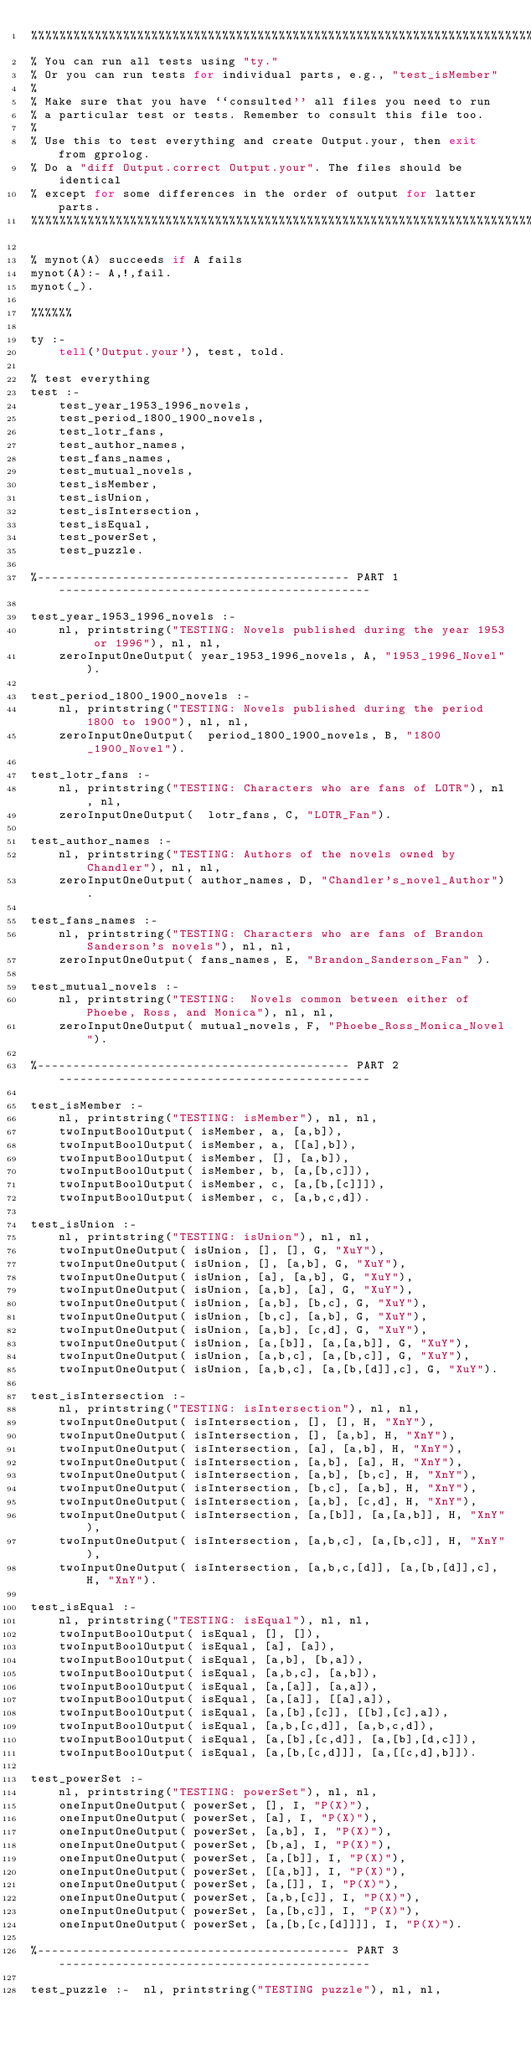<code> <loc_0><loc_0><loc_500><loc_500><_Perl_>%%%%%%%%%%%%%%%%%%%%%%%%%%%%%%%%%%%%%%%%%%%%%%%%%%%%%%%%%%%%%%%%%%%%%%%%%%%
% You can run all tests using "ty." 
% Or you can run tests for individual parts, e.g., "test_isMember"
%
% Make sure that you have ``consulted'' all files you need to run 
% a particular test or tests. Remember to consult this file too.
%
% Use this to test everything and create Output.your, then exit from gprolog.
% Do a "diff Output.correct Output.your". The files should be identical
% except for some differences in the order of output for latter parts.
%%%%%%%%%%%%%%%%%%%%%%%%%%%%%%%%%%%%%%%%%%%%%%%%%%%%%%%%%%%%%%%%%%%%%%%%%%%

% mynot(A) succeeds if A fails
mynot(A):- A,!,fail.
mynot(_).

%%%%%%

ty :-
	tell('Output.your'), test, told.

% test everything
test :-
	test_year_1953_1996_novels,
	test_period_1800_1900_novels,
	test_lotr_fans,
	test_author_names,
	test_fans_names,
	test_mutual_novels,
	test_isMember,
	test_isUnion,
	test_isIntersection,
    test_isEqual,
    test_powerSet,
    test_puzzle.

%-------------------------------------------- PART 1 --------------------------------------------

test_year_1953_1996_novels :-
	nl, printstring("TESTING: Novels published during the year 1953 or 1996"), nl, nl,
	zeroInputOneOutput( year_1953_1996_novels, A, "1953_1996_Novel").

test_period_1800_1900_novels :-
	nl, printstring("TESTING: Novels published during the period 1800 to 1900"), nl, nl,
	zeroInputOneOutput(  period_1800_1900_novels, B, "1800_1900_Novel").

test_lotr_fans :-
	nl, printstring("TESTING: Characters who are fans of LOTR"), nl, nl,
	zeroInputOneOutput(  lotr_fans, C, "LOTR_Fan").

test_author_names :-
	nl, printstring("TESTING: Authors of the novels owned by Chandler"), nl, nl,
	zeroInputOneOutput( author_names, D, "Chandler's_novel_Author").

test_fans_names :-
	nl, printstring("TESTING: Characters who are fans of Brandon Sanderson's novels"), nl, nl,
	zeroInputOneOutput( fans_names, E, "Brandon_Sanderson_Fan" ).

test_mutual_novels :-
	nl, printstring("TESTING:  Novels common between either of Phoebe, Ross, and Monica"), nl, nl,
	zeroInputOneOutput( mutual_novels, F, "Phoebe_Ross_Monica_Novel").

%-------------------------------------------- PART 2 --------------------------------------------

test_isMember :-
	nl, printstring("TESTING: isMember"), nl, nl,
	twoInputBoolOutput( isMember, a, [a,b]),
	twoInputBoolOutput( isMember, a, [[a],b]),
	twoInputBoolOutput( isMember, [], [a,b]),
	twoInputBoolOutput( isMember, b, [a,[b,c]]),
	twoInputBoolOutput( isMember, c, [a,[b,[c]]]),
	twoInputBoolOutput( isMember, c, [a,b,c,d]).

test_isUnion :-
	nl, printstring("TESTING: isUnion"), nl, nl,
	twoInputOneOutput( isUnion, [], [], G, "XuY"),
	twoInputOneOutput( isUnion, [], [a,b], G, "XuY"),
	twoInputOneOutput( isUnion, [a], [a,b], G, "XuY"),
	twoInputOneOutput( isUnion, [a,b], [a], G, "XuY"),
	twoInputOneOutput( isUnion, [a,b], [b,c], G, "XuY"),
	twoInputOneOutput( isUnion, [b,c], [a,b], G, "XuY"),
	twoInputOneOutput( isUnion, [a,b], [c,d], G, "XuY"),
	twoInputOneOutput( isUnion, [a,[b]], [a,[a,b]], G, "XuY"),
	twoInputOneOutput( isUnion, [a,b,c], [a,[b,c]], G, "XuY"),
	twoInputOneOutput( isUnion, [a,b,c], [a,[b,[d]],c], G, "XuY").

test_isIntersection :-
	nl, printstring("TESTING: isIntersection"), nl, nl,
	twoInputOneOutput( isIntersection, [], [], H, "XnY"),
	twoInputOneOutput( isIntersection, [], [a,b], H, "XnY"),
	twoInputOneOutput( isIntersection, [a], [a,b], H, "XnY"),
	twoInputOneOutput( isIntersection, [a,b], [a], H, "XnY"),
	twoInputOneOutput( isIntersection, [a,b], [b,c], H, "XnY"),
	twoInputOneOutput( isIntersection, [b,c], [a,b], H, "XnY"),
	twoInputOneOutput( isIntersection, [a,b], [c,d], H, "XnY"),
	twoInputOneOutput( isIntersection, [a,[b]], [a,[a,b]], H, "XnY"),
	twoInputOneOutput( isIntersection, [a,b,c], [a,[b,c]], H, "XnY"),
	twoInputOneOutput( isIntersection, [a,b,c,[d]], [a,[b,[d]],c], H, "XnY").

test_isEqual :-
	nl, printstring("TESTING: isEqual"), nl, nl,
	twoInputBoolOutput( isEqual, [], []),
	twoInputBoolOutput( isEqual, [a], [a]),
	twoInputBoolOutput( isEqual, [a,b], [b,a]),
	twoInputBoolOutput( isEqual, [a,b,c], [a,b]),
	twoInputBoolOutput( isEqual, [a,[a]], [a,a]),
	twoInputBoolOutput( isEqual, [a,[a]], [[a],a]),
	twoInputBoolOutput( isEqual, [a,[b],[c]], [[b],[c],a]),
	twoInputBoolOutput( isEqual, [a,b,[c,d]], [a,b,c,d]),
	twoInputBoolOutput( isEqual, [a,[b],[c,d]], [a,[b],[d,c]]),
	twoInputBoolOutput( isEqual, [a,[b,[c,d]]], [a,[[c,d],b]]).

test_powerSet :- 
	nl, printstring("TESTING: powerSet"), nl, nl,
	oneInputOneOutput( powerSet, [], I, "P(X)"),
	oneInputOneOutput( powerSet, [a], I, "P(X)"),
	oneInputOneOutput( powerSet, [a,b], I, "P(X)"),
	oneInputOneOutput( powerSet, [b,a], I, "P(X)"),
	oneInputOneOutput( powerSet, [a,[b]], I, "P(X)"),
	oneInputOneOutput( powerSet, [[a,b]], I, "P(X)"),
	oneInputOneOutput( powerSet, [a,[]], I, "P(X)"),
	oneInputOneOutput( powerSet, [a,b,[c]], I, "P(X)"),
	oneInputOneOutput( powerSet, [a,[b,c]], I, "P(X)"),
	oneInputOneOutput( powerSet, [a,[b,[c,[d]]]], I, "P(X)").

%-------------------------------------------- PART 3 --------------------------------------------

test_puzzle :-  nl, printstring("TESTING puzzle"), nl, nl,</code> 